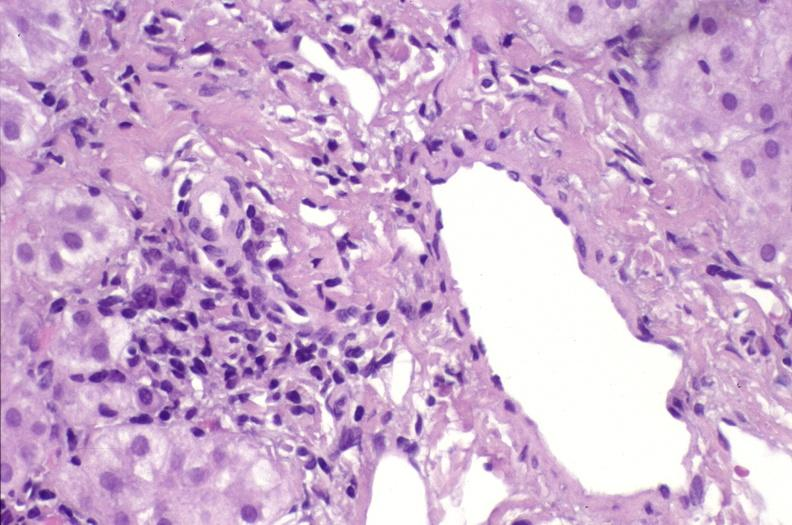what does this image show?
Answer the question using a single word or phrase. Ductopenia 